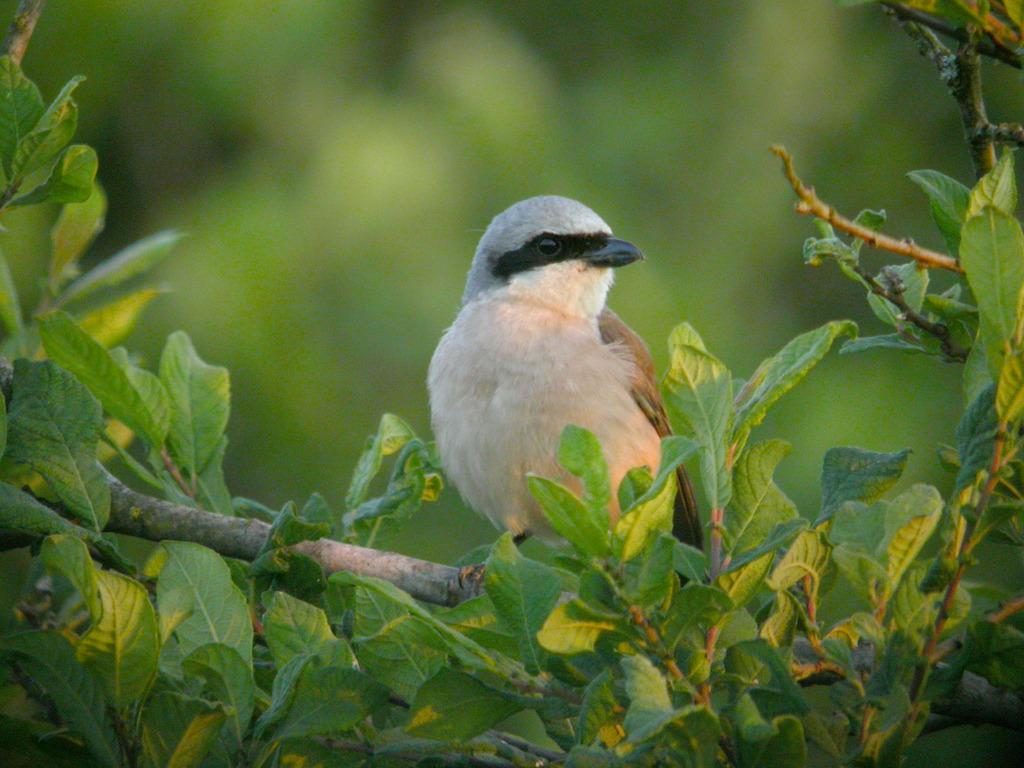What is the main subject in the center of the image? There is a bird in the center of the image. What is the bird resting on? The bird is on a stem. What type of vegetation can be seen at the bottom of the image? Leaves are visible at the bottom of the image. How would you describe the background of the image? The background of the image is blurry. What type of beast is interacting with the bird in the image? There is no beast present in the image; it only features a bird on a stem with leaves at the bottom and a blurry background. 